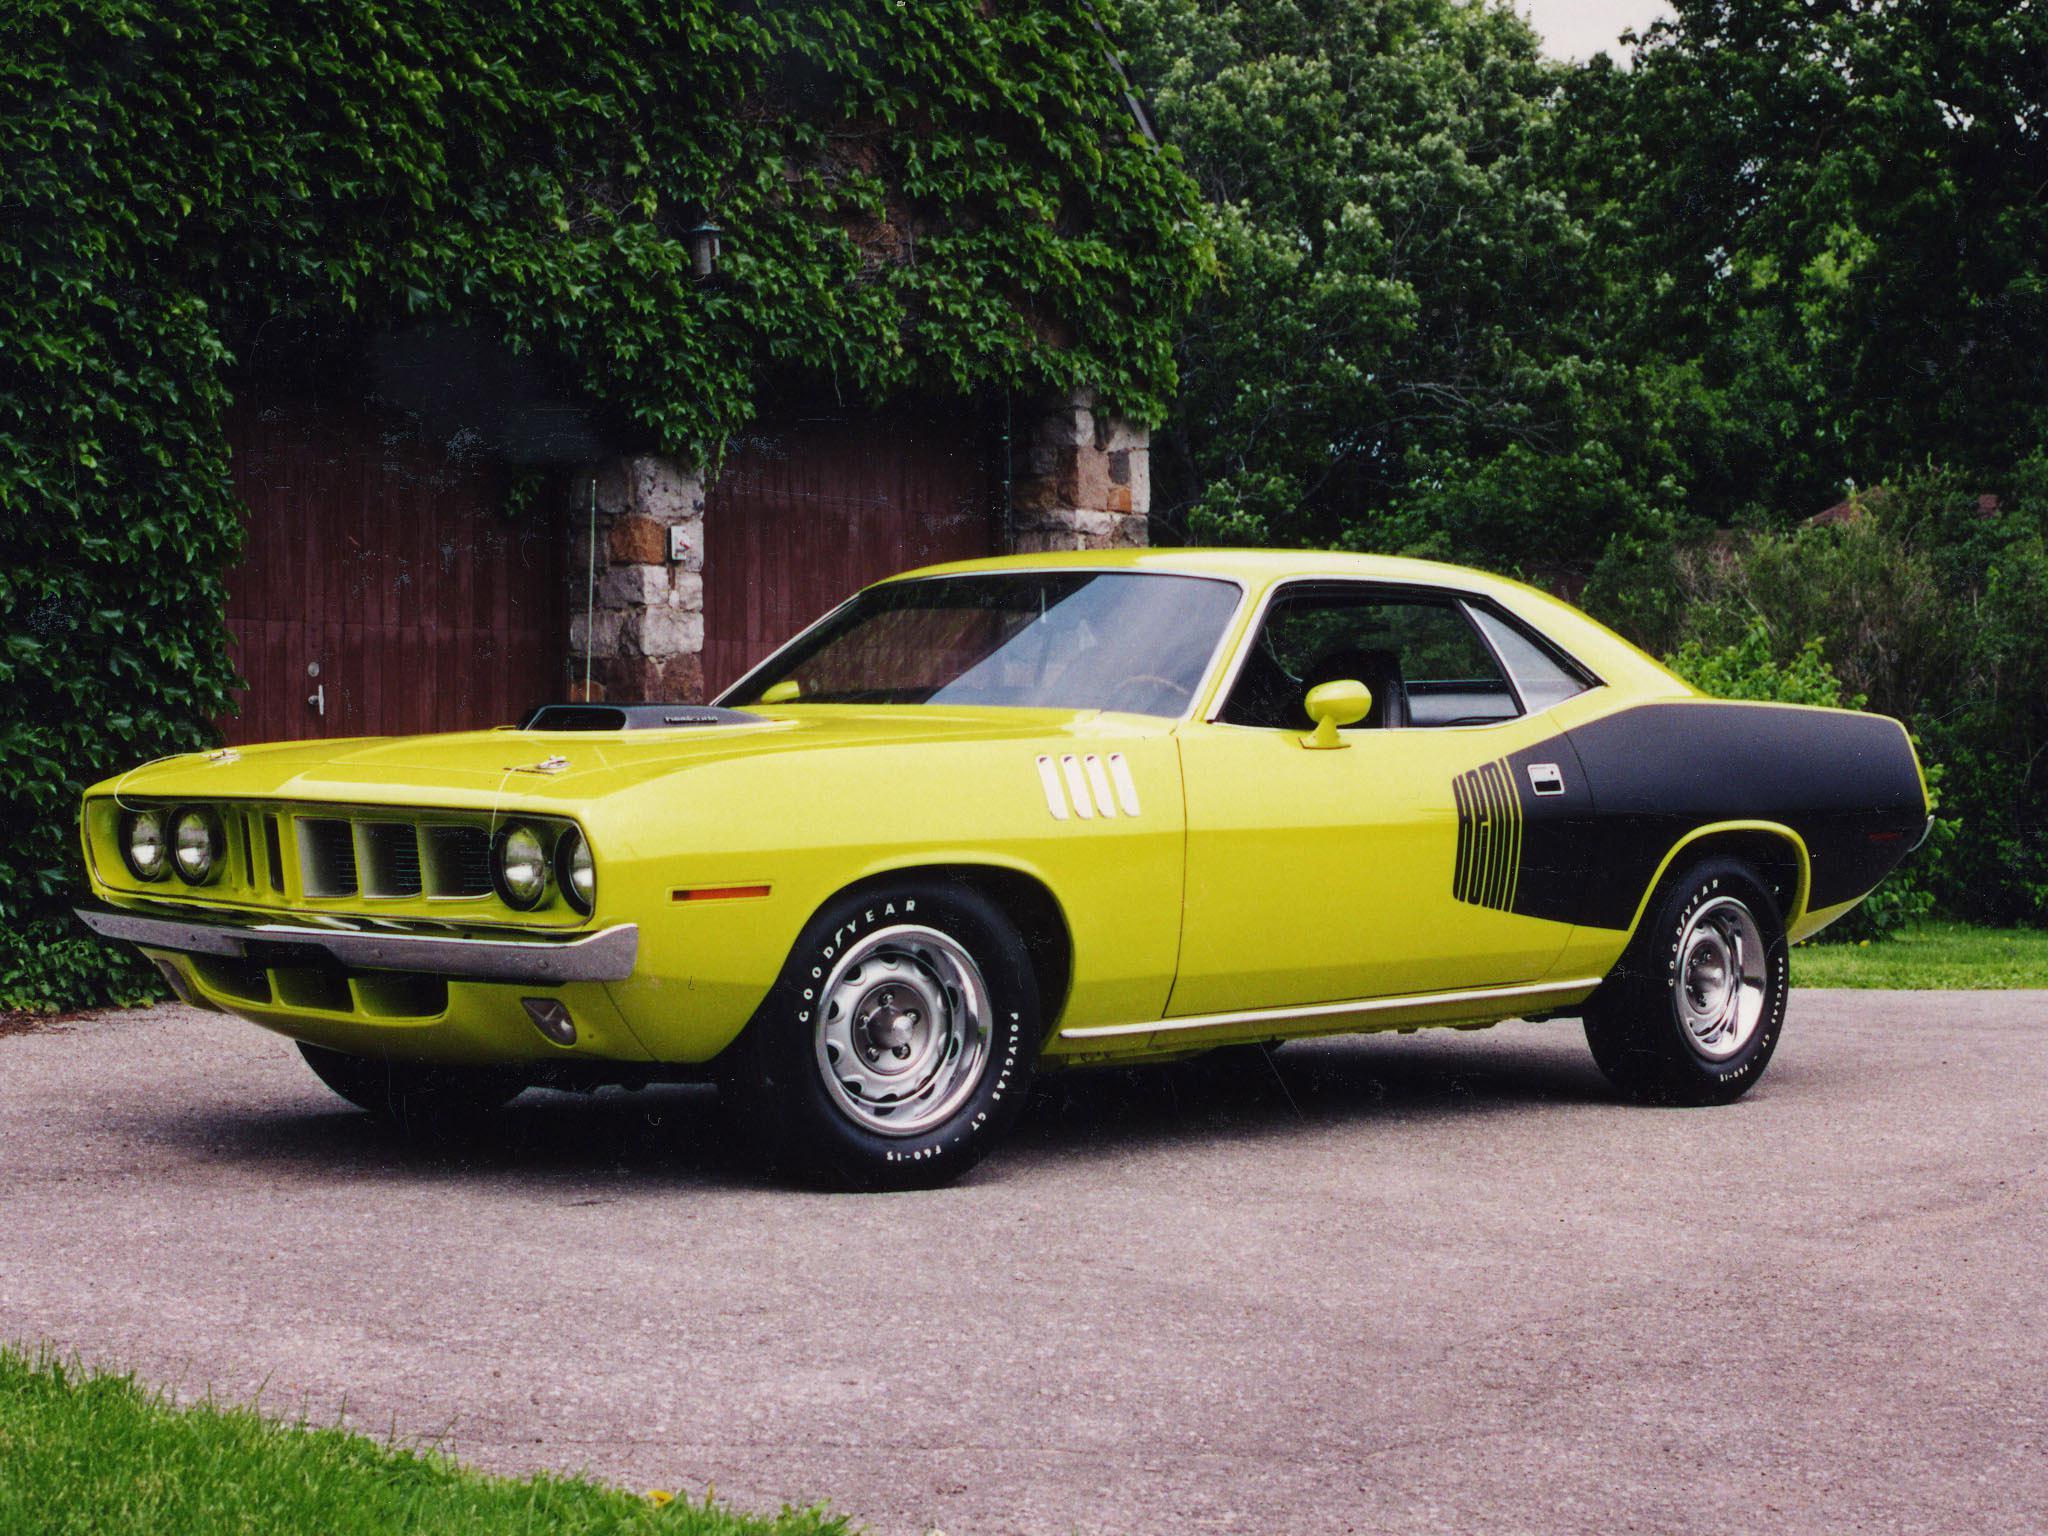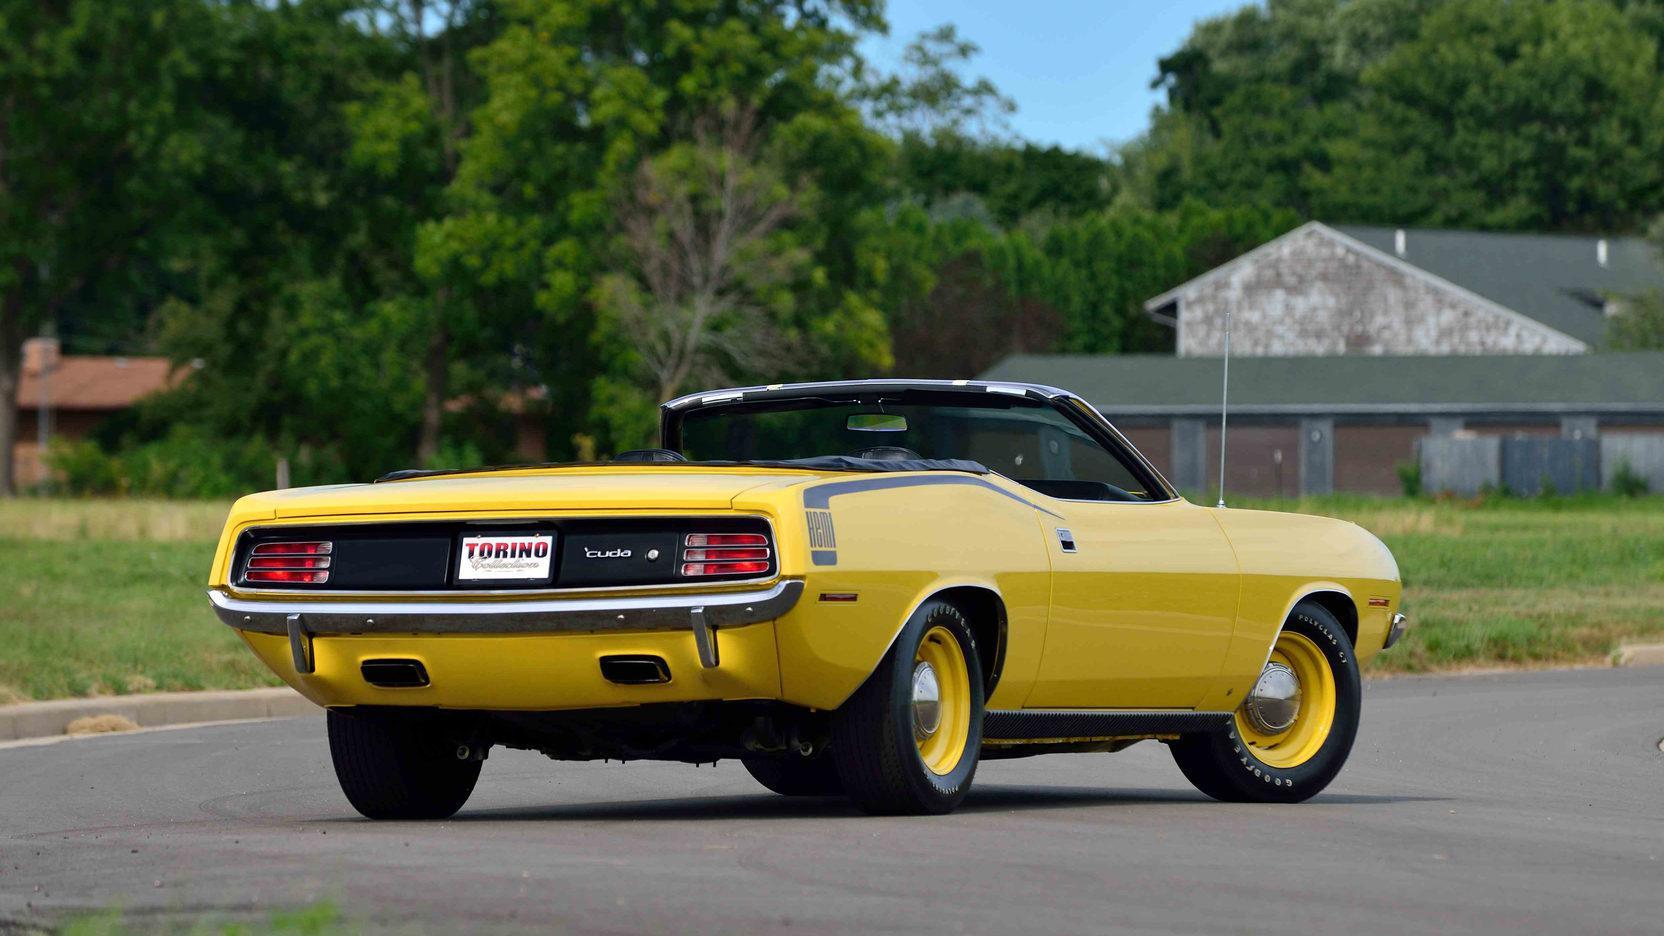The first image is the image on the left, the second image is the image on the right. Considering the images on both sides, is "At least one image features a yellow car in the foreground." valid? Answer yes or no. Yes. 